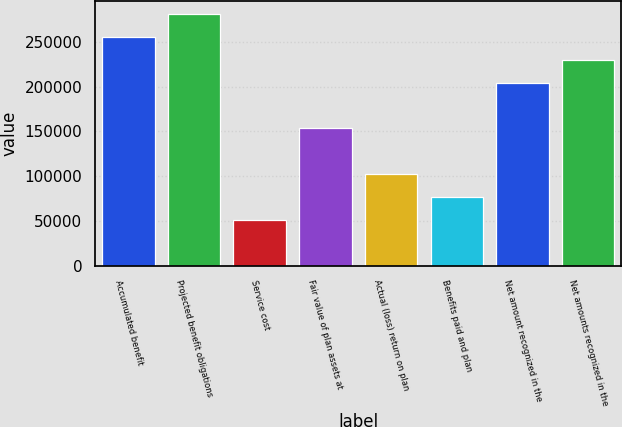Convert chart. <chart><loc_0><loc_0><loc_500><loc_500><bar_chart><fcel>Accumulated benefit<fcel>Projected benefit obligations<fcel>Service cost<fcel>Fair value of plan assets at<fcel>Actual (loss) return on plan<fcel>Benefits paid and plan<fcel>Net amount recognized in the<fcel>Net amounts recognized in the<nl><fcel>255598<fcel>281158<fcel>51122.1<fcel>153360<fcel>102241<fcel>76681.6<fcel>204479<fcel>230039<nl></chart> 